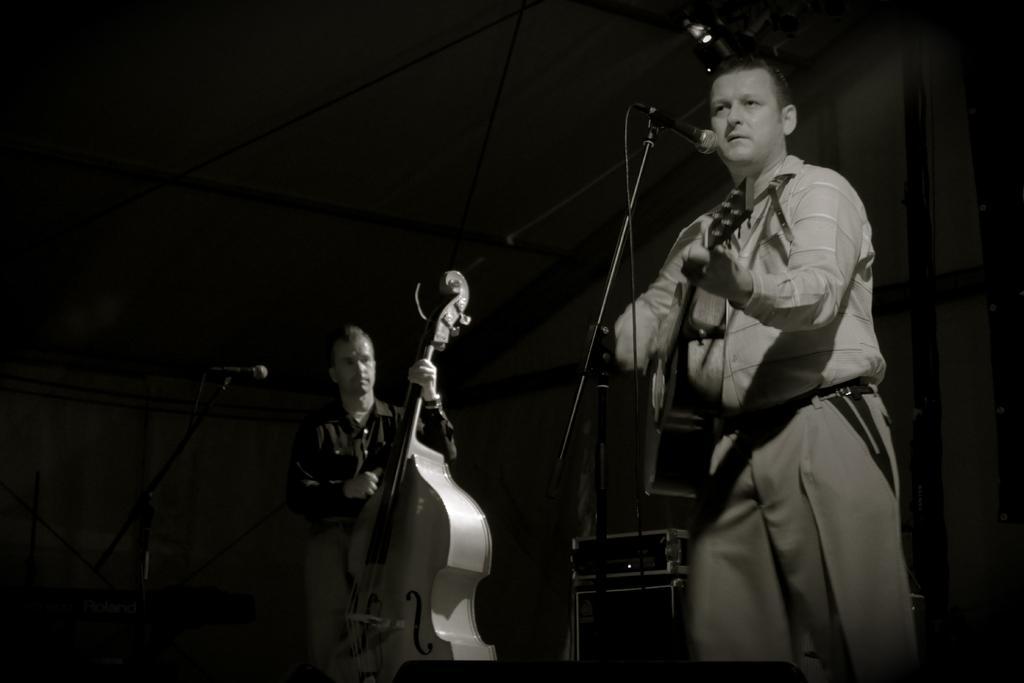In one or two sentences, can you explain what this image depicts? In the picture we can find a two men and the two men are holding a guitar, one man is near to microphone. In the background we can find a dark wall and it is a dark room. 